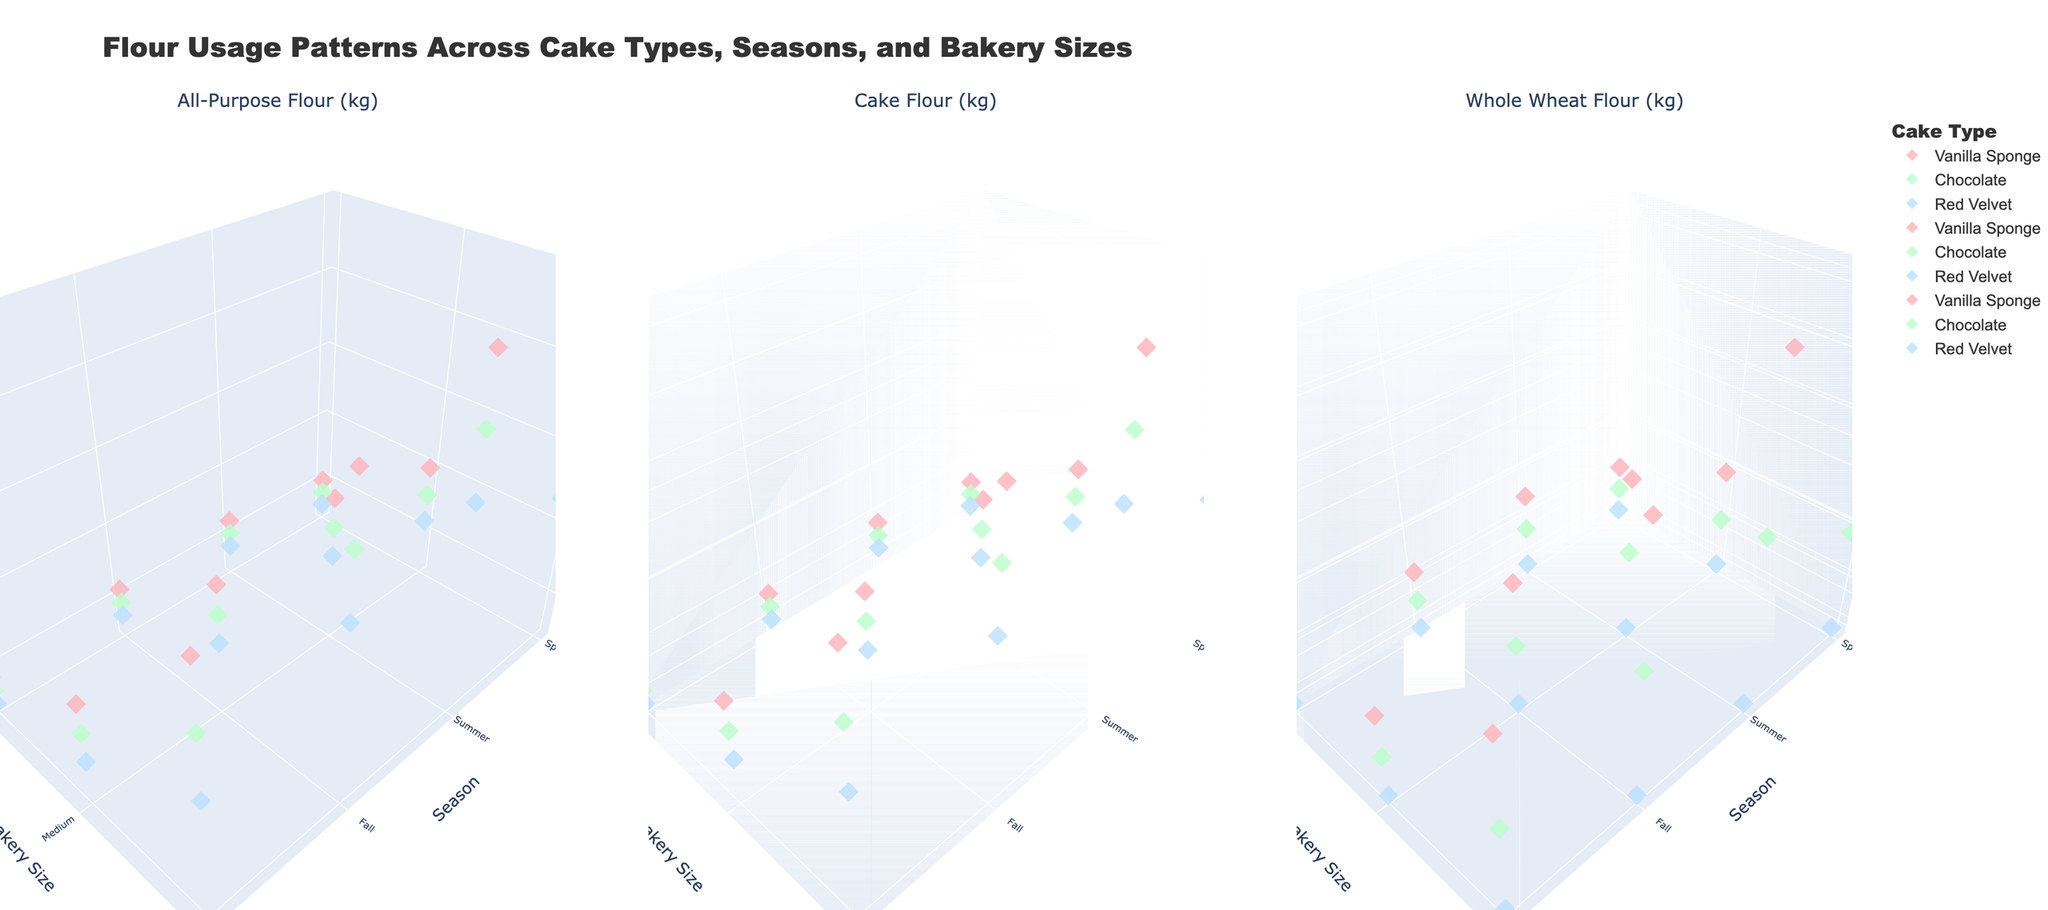What's the title of the figure? The title of the figure can be seen at the top of the plot.
Answer: Flour Usage Patterns Across Cake Types, Seasons, and Bakery Sizes What are the three types of flour represented in the subplots? You can identify the flour types by referring to the subplot titles.
Answer: All-Purpose Flour, Cake Flour, Whole Wheat Flour Which cake type uses the least whole wheat flour during winter across all bakery sizes? Examine the third subplot (Whole Wheat Flour) for winter data points. Red Velvet has consistently zero values for all bakery sizes.
Answer: Red Velvet In the medium bakery size, which cake type uses the most all-purpose flour during summer? Look at the first subplot (All-Purpose Flour) for medium-sized bakeries in summer and compare the values for each cake type. Vanilla Sponge shows the highest value.
Answer: Vanilla Sponge For large bakery sizes, what is the difference in cake flour usage between Vanilla Sponge and Chocolate in fall? In the second subplot (Cake Flour), identify the fall data points for large bakeries; Vanilla Sponge uses 320 kg, and Chocolate uses 260 kg, giving a difference of 60 kg.
Answer: 60 kg Does any cake type use whole wheat flour exclusively in small bakery sizes? Scan the whole wheat flour subplot (third subplot) for small bakery sizes; Red Velvet consistently uses 0 kg of whole wheat flour across all seasons.
Answer: No Which season sees the highest usage of all-purpose flour for the Chocolate cake in large bakery sizes? Inspect the first subplot (All-Purpose Flour) for large bakeries across all seasons; Summer shows a usage of 200 kg.
Answer: Summer Considering all types of flour, which bakery size trends towards the highest flour usage for Red Velvet cakes? Observe all subplots for Red Velvet cakes across all bakery sizes; large bakery sizes have higher flour usage compared to small and medium sizes.
Answer: Large Which season shows the highest aggregated flour usage for Vanilla Sponge in small bakeries? Sum the values for all three types of flour for each season in small bakery sizes for Vanilla Sponge; Summer's cumulative usage is the highest.
Answer: Summer In the Cake Flour subplot, which bakery size and season combination shows the lowest flour usage for Chocolate cakes? In the Cake Flour subplot, identify points for Chocolate cake; small-sized bakeries in winter show the lowest value at 55 kg.
Answer: Small, Winter 